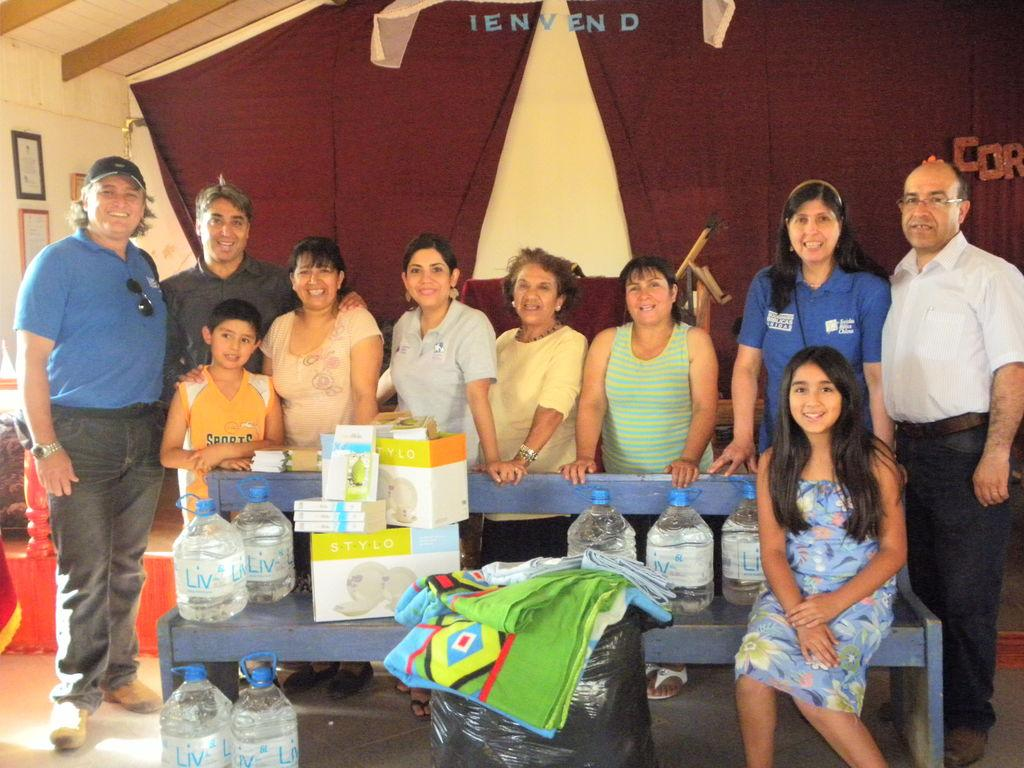What is happening in the image involving a group of people? There is a group of people in the image, but the specific activity is not mentioned in the facts. Can you describe the girl's position in the image? The girl is sitting on a bench. What items can be seen on the bench? There are books and cardboard boxes on the bench. Are there any other books visible in the image? Yes, there are more books on the bench. What can be seen on the wall in the image? There are photos on the wall. How does the girl use paste to attach the trousers to the swing in the image? There is no mention of paste, trousers, or a swing in the image. 